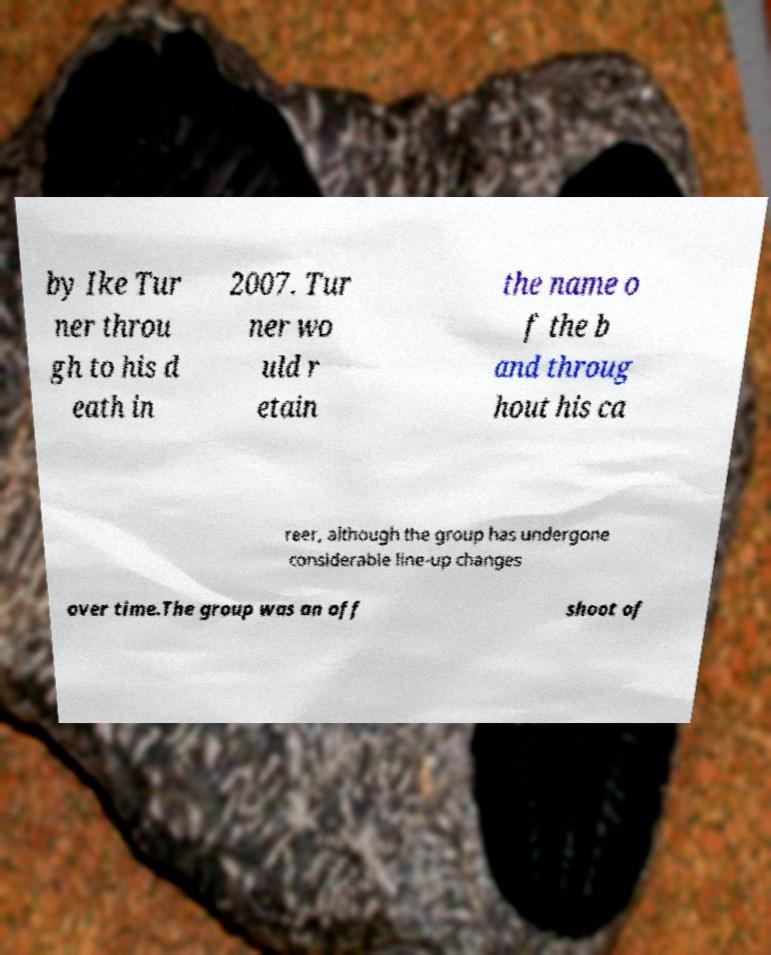Could you assist in decoding the text presented in this image and type it out clearly? by Ike Tur ner throu gh to his d eath in 2007. Tur ner wo uld r etain the name o f the b and throug hout his ca reer, although the group has undergone considerable line-up changes over time.The group was an off shoot of 